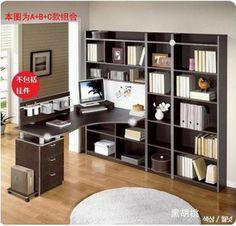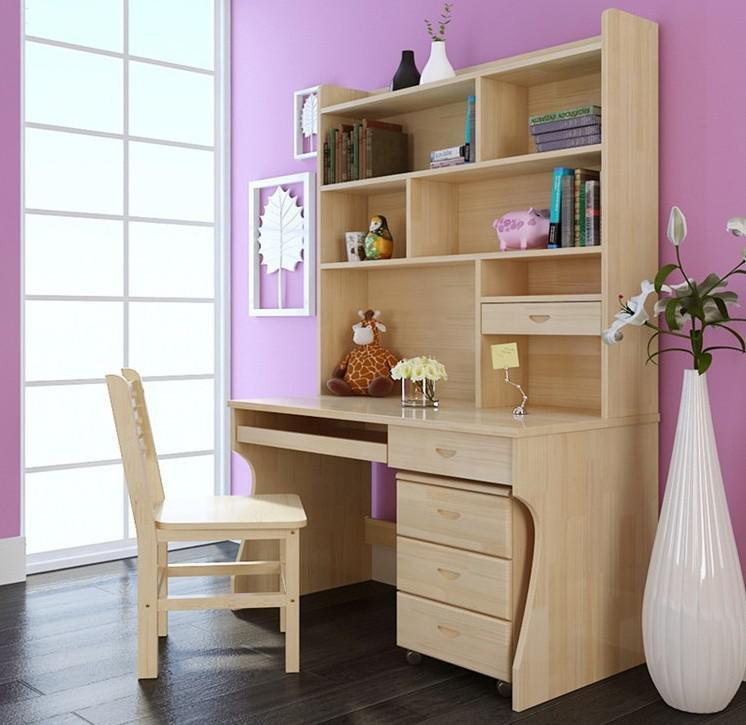The first image is the image on the left, the second image is the image on the right. Evaluate the accuracy of this statement regarding the images: "In one image a white desk and shelf unit has one narrow end against a wall, while the other image is a white shelf unit flush to the wall with a chair in front of it.". Is it true? Answer yes or no. No. The first image is the image on the left, the second image is the image on the right. For the images shown, is this caption "An image shows a white storage piece with its taller end flush against a wall and a computer atop the desk part." true? Answer yes or no. No. 